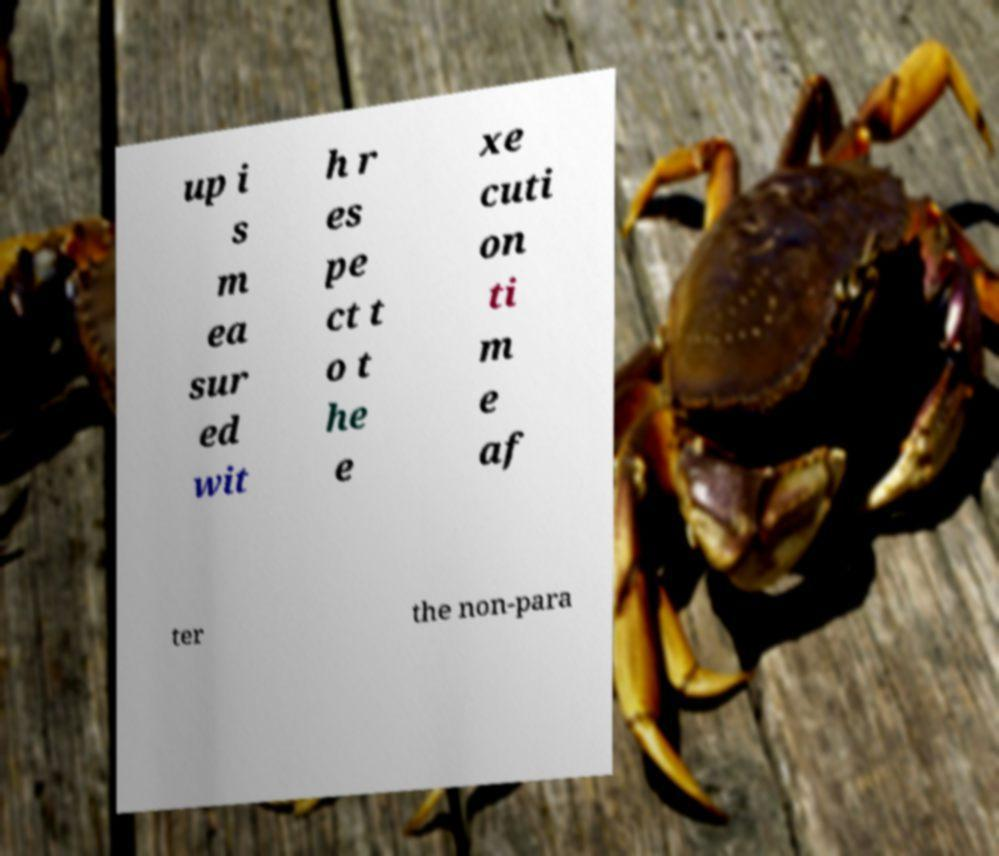Can you accurately transcribe the text from the provided image for me? up i s m ea sur ed wit h r es pe ct t o t he e xe cuti on ti m e af ter the non-para 